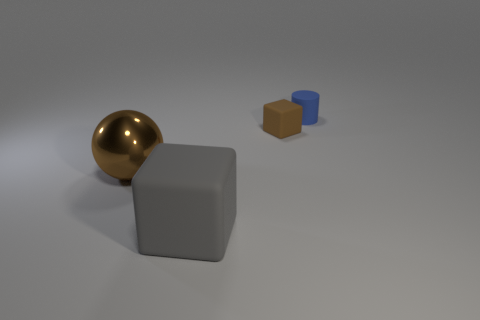Add 3 cyan cylinders. How many objects exist? 7 Subtract all gray blocks. How many blocks are left? 1 Subtract all cylinders. How many objects are left? 3 Add 3 large blocks. How many large blocks are left? 4 Add 2 small things. How many small things exist? 4 Subtract 0 yellow cylinders. How many objects are left? 4 Subtract all purple blocks. Subtract all green spheres. How many blocks are left? 2 Subtract all yellow balls. How many gray blocks are left? 1 Subtract all large balls. Subtract all purple rubber objects. How many objects are left? 3 